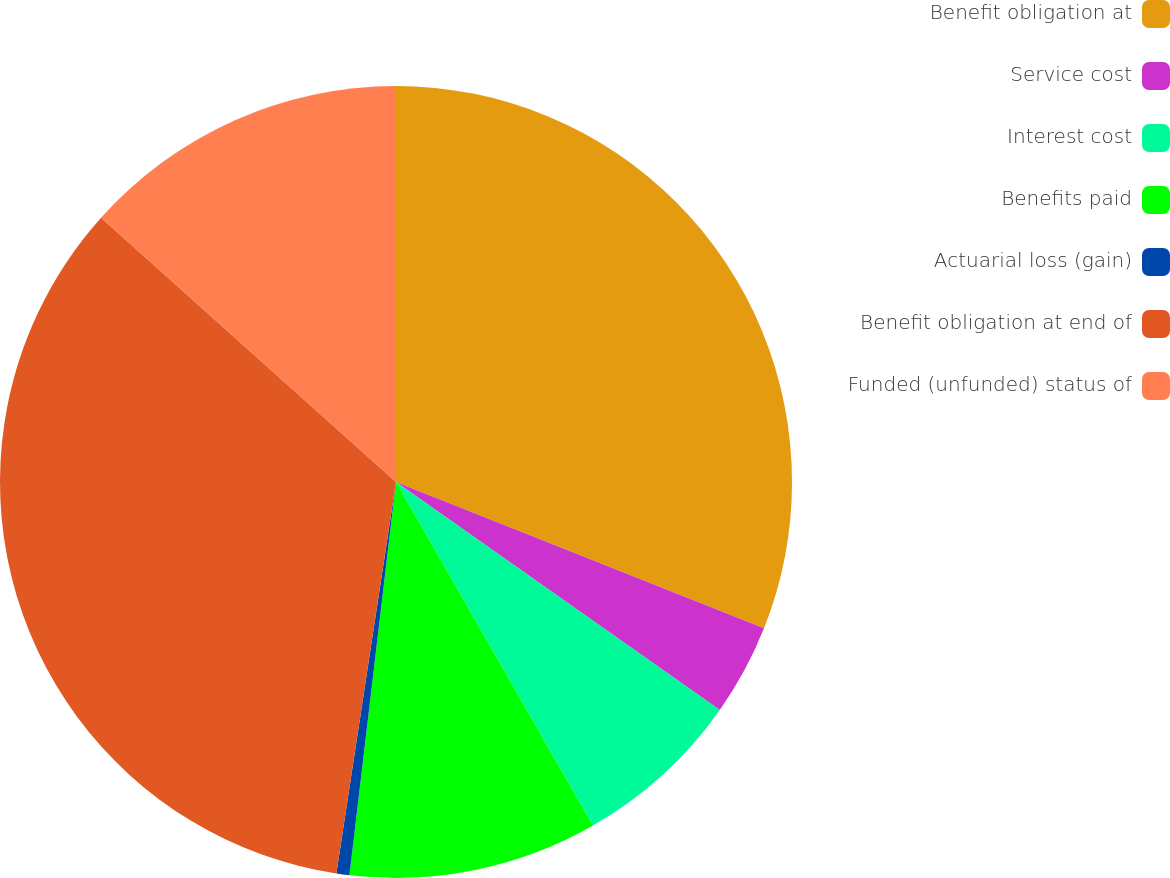Convert chart. <chart><loc_0><loc_0><loc_500><loc_500><pie_chart><fcel>Benefit obligation at<fcel>Service cost<fcel>Interest cost<fcel>Benefits paid<fcel>Actuarial loss (gain)<fcel>Benefit obligation at end of<fcel>Funded (unfunded) status of<nl><fcel>31.02%<fcel>3.74%<fcel>6.95%<fcel>10.16%<fcel>0.53%<fcel>34.22%<fcel>13.37%<nl></chart> 